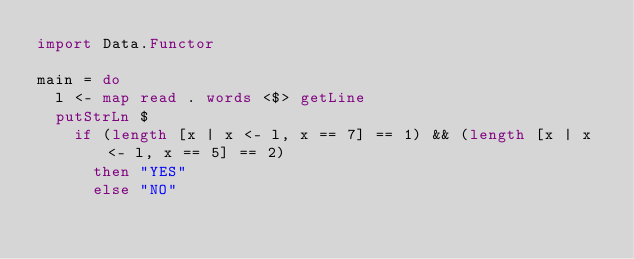<code> <loc_0><loc_0><loc_500><loc_500><_Haskell_>import Data.Functor

main = do
  l <- map read . words <$> getLine
  putStrLn $ 
    if (length [x | x <- l, x == 7] == 1) && (length [x | x <- l, x == 5] == 2)
      then "YES"
      else "NO"</code> 